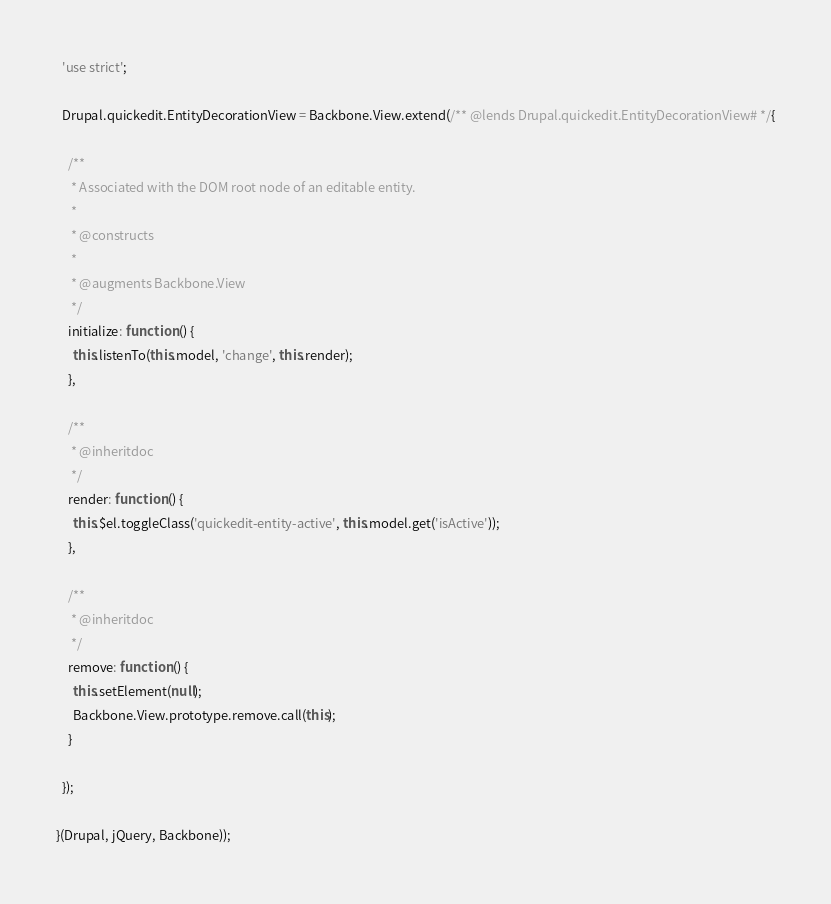Convert code to text. <code><loc_0><loc_0><loc_500><loc_500><_JavaScript_>  'use strict';

  Drupal.quickedit.EntityDecorationView = Backbone.View.extend(/** @lends Drupal.quickedit.EntityDecorationView# */{

    /**
     * Associated with the DOM root node of an editable entity.
     *
     * @constructs
     *
     * @augments Backbone.View
     */
    initialize: function () {
      this.listenTo(this.model, 'change', this.render);
    },

    /**
     * @inheritdoc
     */
    render: function () {
      this.$el.toggleClass('quickedit-entity-active', this.model.get('isActive'));
    },

    /**
     * @inheritdoc
     */
    remove: function () {
      this.setElement(null);
      Backbone.View.prototype.remove.call(this);
    }

  });

}(Drupal, jQuery, Backbone));
</code> 